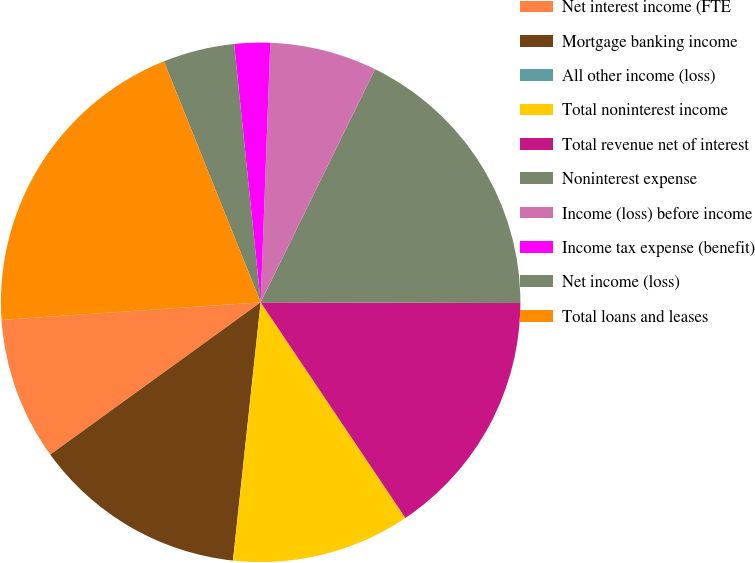Convert chart to OTSL. <chart><loc_0><loc_0><loc_500><loc_500><pie_chart><fcel>Net interest income (FTE<fcel>Mortgage banking income<fcel>All other income (loss)<fcel>Total noninterest income<fcel>Total revenue net of interest<fcel>Noninterest expense<fcel>Income (loss) before income<fcel>Income tax expense (benefit)<fcel>Net income (loss)<fcel>Total loans and leases<nl><fcel>8.89%<fcel>13.33%<fcel>0.0%<fcel>11.11%<fcel>15.55%<fcel>17.78%<fcel>6.67%<fcel>2.22%<fcel>4.45%<fcel>20.0%<nl></chart> 